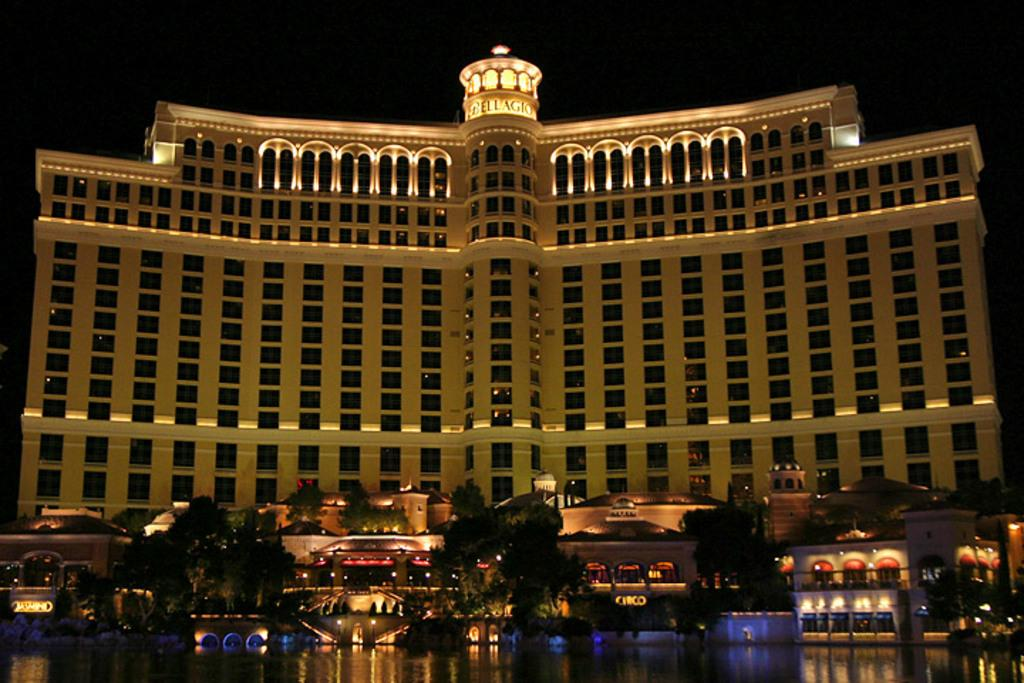What type of structure is visible in the image? There is a building in the image. What type of vegetation can be seen in the image? There are trees in the image. What else is visible in the image besides the building and trees? There are lights in the image. What type of stamp can be seen on the building in the image? There is no stamp visible on the building in the image. What news is being reported by the trees in the image? The trees in the image are not reporting any news; they are simply vegetation. 